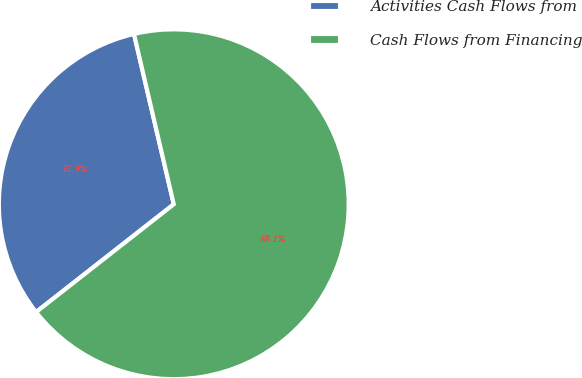<chart> <loc_0><loc_0><loc_500><loc_500><pie_chart><fcel>Activities Cash Flows from<fcel>Cash Flows from Financing<nl><fcel>31.92%<fcel>68.08%<nl></chart> 